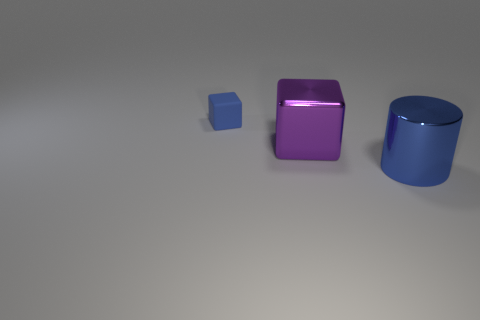Add 1 big red cylinders. How many objects exist? 4 Subtract all cylinders. How many objects are left? 2 Subtract all blue matte cubes. Subtract all big metallic blocks. How many objects are left? 1 Add 3 big metallic things. How many big metallic things are left? 5 Add 1 tiny things. How many tiny things exist? 2 Subtract 0 purple cylinders. How many objects are left? 3 